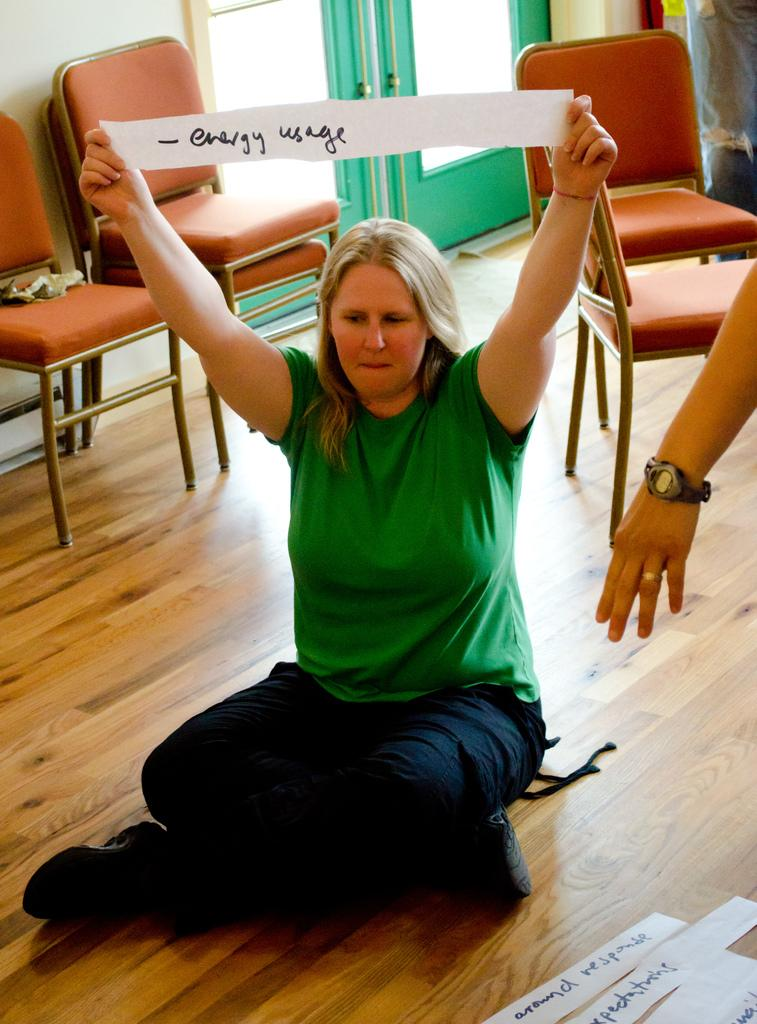What can be seen in the background of the image? There is a door and chairs in the background of the image. What is the woman in the image doing? The woman is sitting on the floor in the image. What is the woman holding in the image? The woman is holding a paper with the words "Energy Usage" on it. What else is on the floor in the image? There are papers on the floor in the image. What type of apparel is the woman wearing to plough the field in the image? There is no plough or field present in the image, and the woman is not wearing any apparel for ploughing. How many noses can be seen in the image? There is only one woman in the image, and she has one nose. 